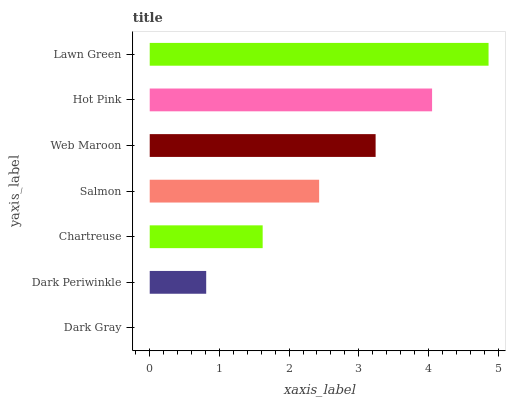Is Dark Gray the minimum?
Answer yes or no. Yes. Is Lawn Green the maximum?
Answer yes or no. Yes. Is Dark Periwinkle the minimum?
Answer yes or no. No. Is Dark Periwinkle the maximum?
Answer yes or no. No. Is Dark Periwinkle greater than Dark Gray?
Answer yes or no. Yes. Is Dark Gray less than Dark Periwinkle?
Answer yes or no. Yes. Is Dark Gray greater than Dark Periwinkle?
Answer yes or no. No. Is Dark Periwinkle less than Dark Gray?
Answer yes or no. No. Is Salmon the high median?
Answer yes or no. Yes. Is Salmon the low median?
Answer yes or no. Yes. Is Web Maroon the high median?
Answer yes or no. No. Is Dark Gray the low median?
Answer yes or no. No. 